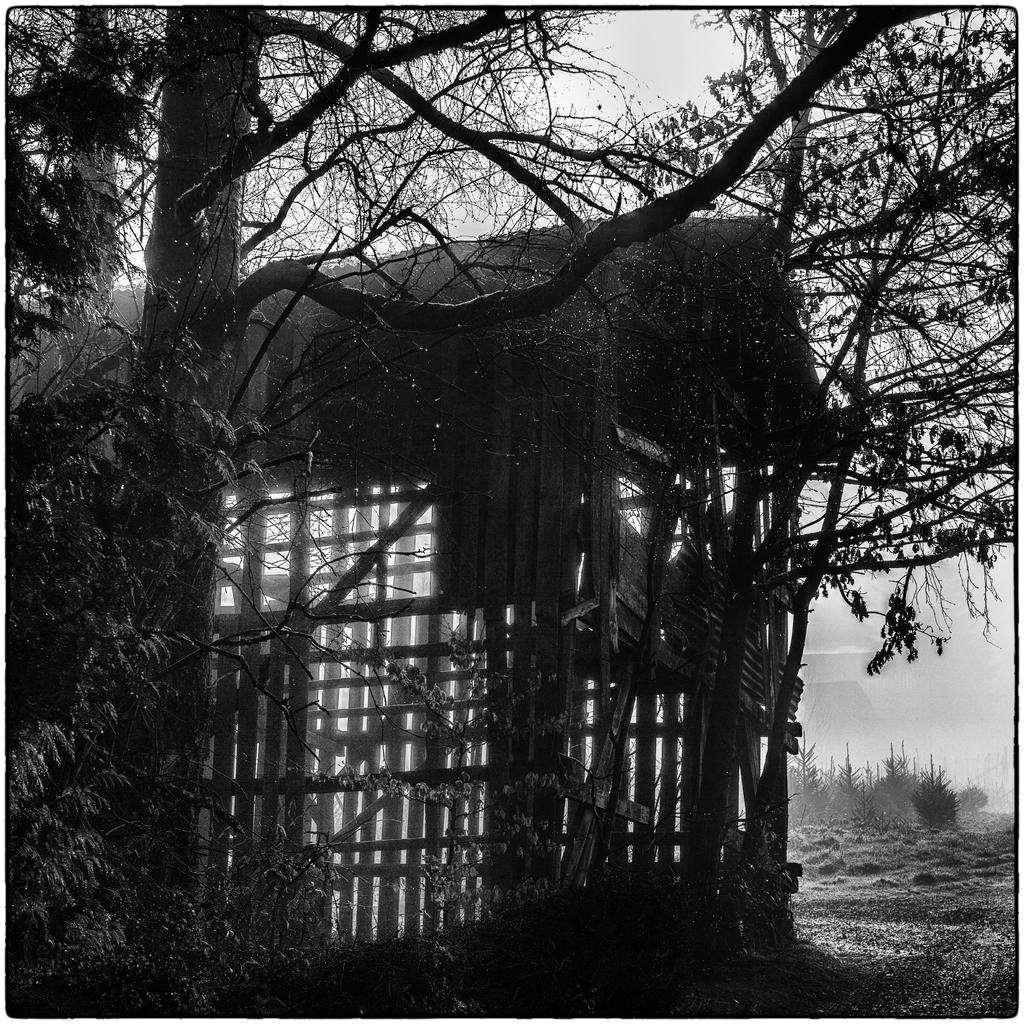What type of house is in the image? There is a wooden house in the image. How is the wooden house constructed? The wooden house is made of wooden logs. What other natural elements can be seen in the image? There is a tree, the sky, the ground, and plants visible in the image. Where is the drawer located in the image? There is no drawer present in the image. How many flies can be seen on the wooden house in the image? There are no flies visible in the image. 